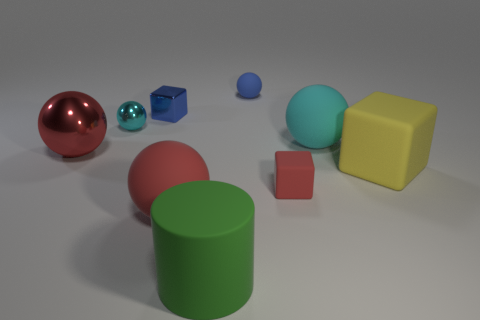What materials do the objects in the image appear to be made of? The materials of the objects vary, the spheres look like they could be made of polished metal or a shiny plastic, while the cube and the blocks appear to be matte, suggestive of a rubbery texture. The cylinder has a diffuse surface which could imply a ceramic or painted wood construction. 